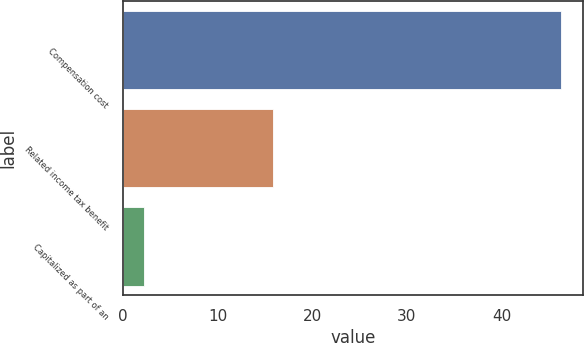<chart> <loc_0><loc_0><loc_500><loc_500><bar_chart><fcel>Compensation cost<fcel>Related income tax benefit<fcel>Capitalized as part of an<nl><fcel>46.3<fcel>15.8<fcel>2.2<nl></chart> 